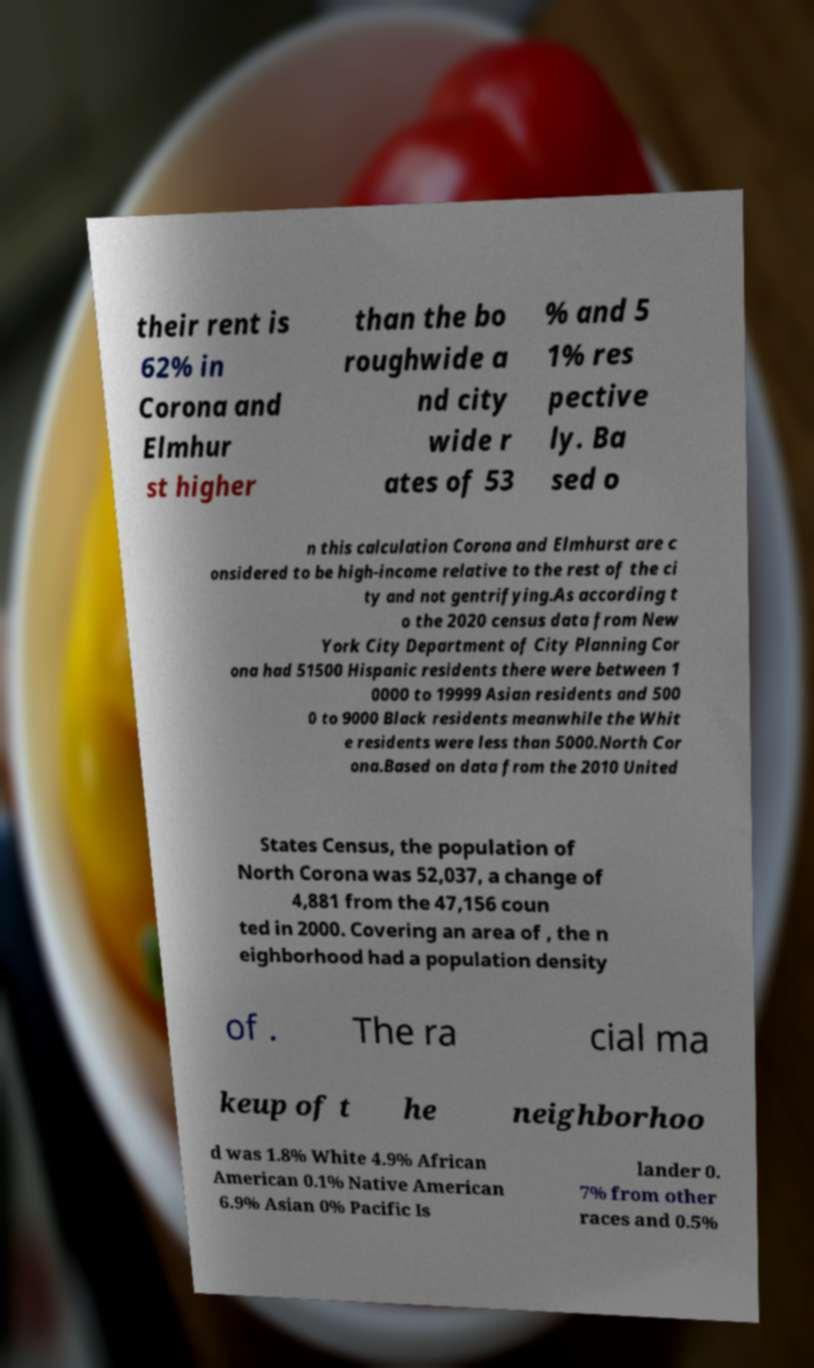Could you extract and type out the text from this image? their rent is 62% in Corona and Elmhur st higher than the bo roughwide a nd city wide r ates of 53 % and 5 1% res pective ly. Ba sed o n this calculation Corona and Elmhurst are c onsidered to be high-income relative to the rest of the ci ty and not gentrifying.As according t o the 2020 census data from New York City Department of City Planning Cor ona had 51500 Hispanic residents there were between 1 0000 to 19999 Asian residents and 500 0 to 9000 Black residents meanwhile the Whit e residents were less than 5000.North Cor ona.Based on data from the 2010 United States Census, the population of North Corona was 52,037, a change of 4,881 from the 47,156 coun ted in 2000. Covering an area of , the n eighborhood had a population density of . The ra cial ma keup of t he neighborhoo d was 1.8% White 4.9% African American 0.1% Native American 6.9% Asian 0% Pacific Is lander 0. 7% from other races and 0.5% 